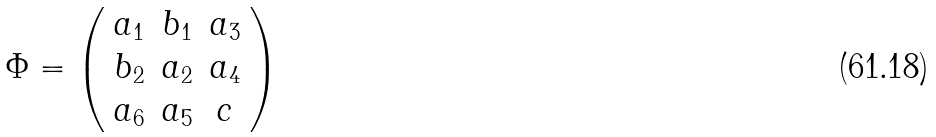<formula> <loc_0><loc_0><loc_500><loc_500>\Phi = \left ( \begin{array} { c c c } a _ { 1 } & b _ { 1 } & a _ { 3 } \\ b _ { 2 } & a _ { 2 } & a _ { 4 } \\ a _ { 6 } & a _ { 5 } & c \end{array} \right )</formula> 